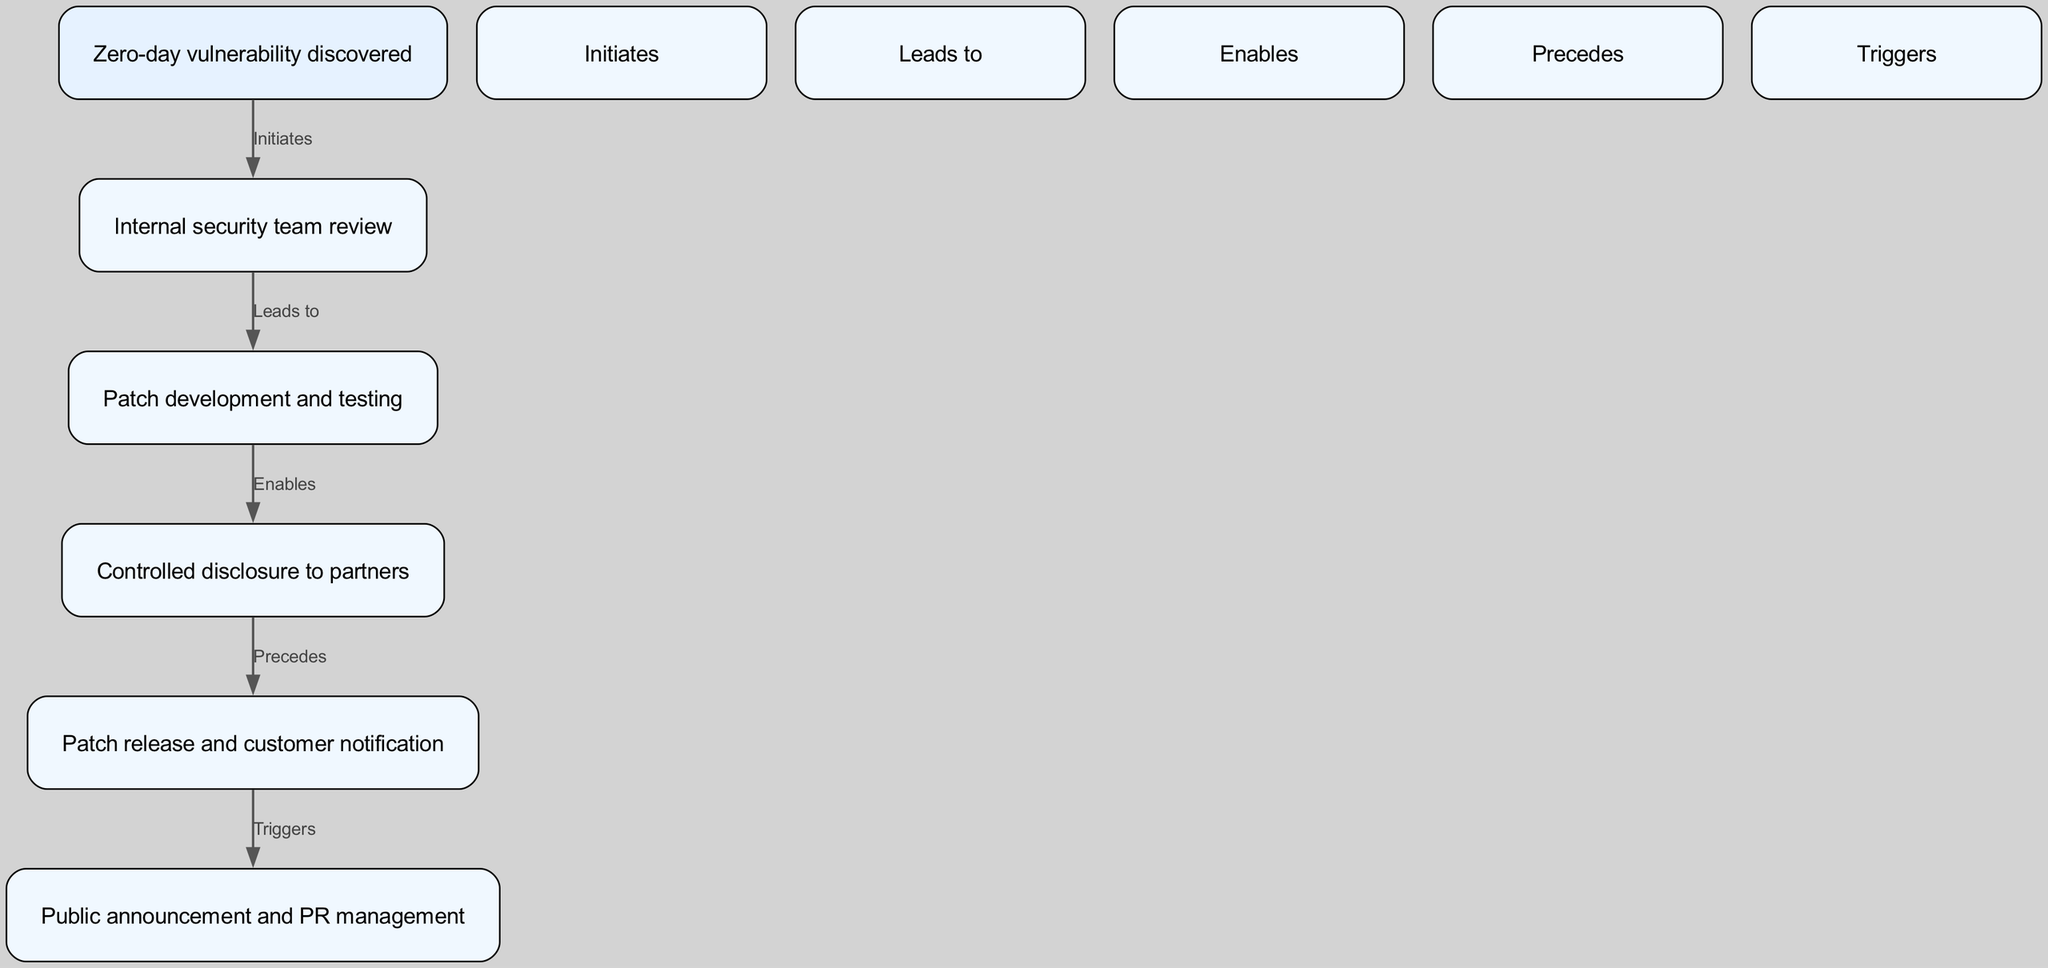What initiates the internal review process? The diagram indicates that a zero-day vulnerability discovered initiates the internal review. This is shown as the starting point that leads to the review conducted by the internal security team.
Answer: Zero-day vulnerability discovered What comes before the patch release? According to the diagram flow, the controlled disclosure to partners precedes the patch release. This indicates that after informing partners, a patch can be released.
Answer: Controlled disclosure to partners How many nodes are present in this diagram? The diagram lists a total of six nodes, which represent the various stages in the software vulnerability patching process. Each unique stage is a node in this network.
Answer: Six What triggers the public announcement? The diagram shows that the patch release triggers the public announcement. This indicates that once the patch is released, the next step is to make an announcement to the public.
Answer: Patch release What enables the controlled disclosure? The patch development and testing process enables the controlled disclosure to partners, as it prepares the team to share the information safely and effectively once testing is complete.
Answer: Patch development and testing How many edges connect the nodes in this diagram? There are five edges connecting the nodes, representing the relationships and flow between the different stages of the patching process.
Answer: Five What leads to the patch development? The internal security team review leads to the patch development. This implies that once the review is complete, the necessary actions to develop a patch follow.
Answer: Internal security team review What is the final stage of the process depicted in the diagram? The final stage illustrated in the diagram is the public announcement and PR management, which indicates that after all preceding steps, a public communication is made.
Answer: Public announcement and PR management What is the relationship between patch release and public announcement? The diagram specifies that the patch release triggers the public announcement, which means that the announcement follows directly after the patch is made available.
Answer: Triggers 